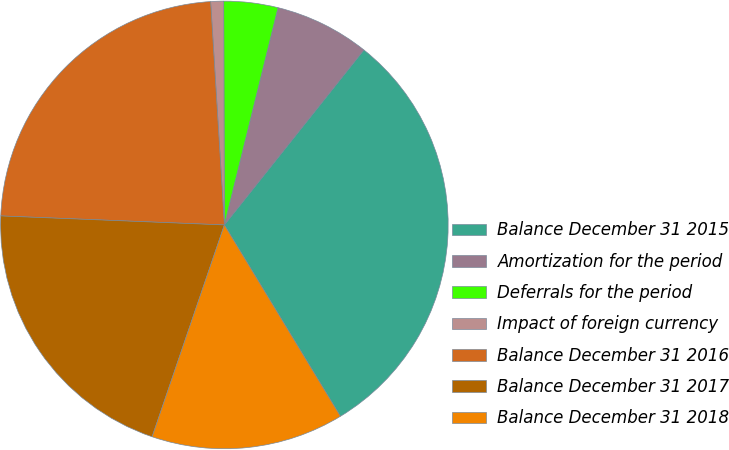Convert chart to OTSL. <chart><loc_0><loc_0><loc_500><loc_500><pie_chart><fcel>Balance December 31 2015<fcel>Amortization for the period<fcel>Deferrals for the period<fcel>Impact of foreign currency<fcel>Balance December 31 2016<fcel>Balance December 31 2017<fcel>Balance December 31 2018<nl><fcel>30.61%<fcel>6.86%<fcel>3.9%<fcel>0.93%<fcel>23.38%<fcel>20.41%<fcel>13.91%<nl></chart> 